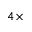Convert formula to latex. <formula><loc_0><loc_0><loc_500><loc_500>4 \times</formula> 